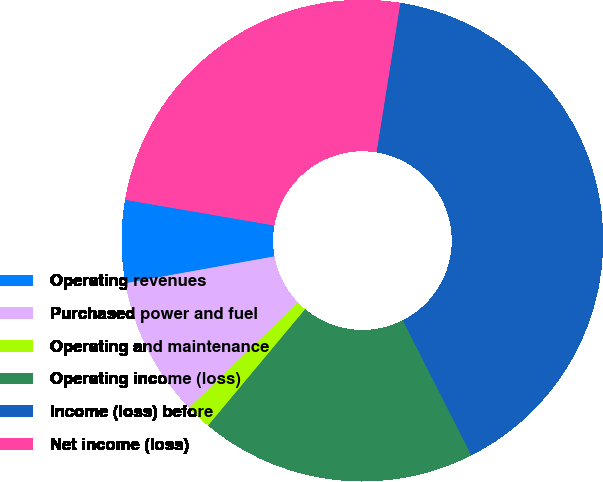<chart> <loc_0><loc_0><loc_500><loc_500><pie_chart><fcel>Operating revenues<fcel>Purchased power and fuel<fcel>Operating and maintenance<fcel>Operating income (loss)<fcel>Income (loss) before<fcel>Net income (loss)<nl><fcel>5.55%<fcel>9.38%<fcel>1.72%<fcel>18.54%<fcel>40.01%<fcel>24.8%<nl></chart> 